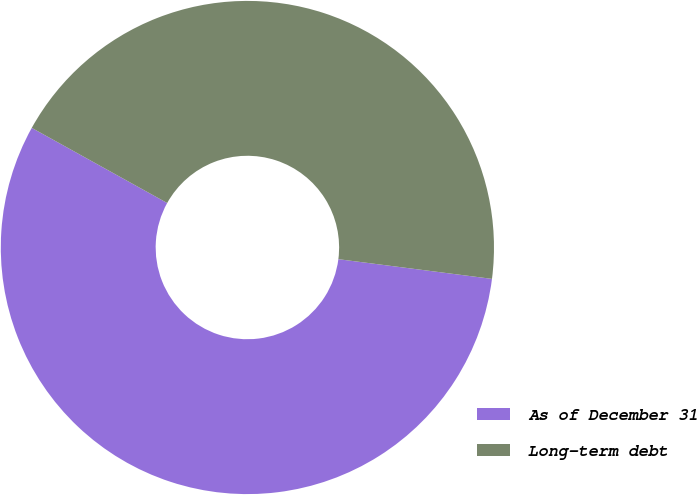Convert chart. <chart><loc_0><loc_0><loc_500><loc_500><pie_chart><fcel>As of December 31<fcel>Long-term debt<nl><fcel>56.03%<fcel>43.97%<nl></chart> 